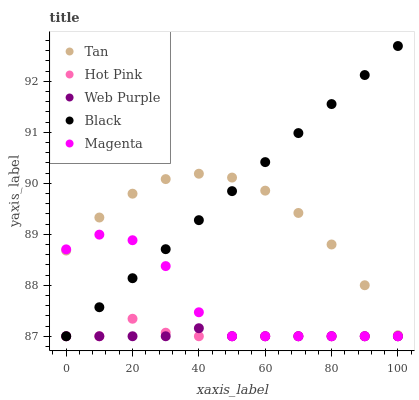Does Web Purple have the minimum area under the curve?
Answer yes or no. Yes. Does Black have the maximum area under the curve?
Answer yes or no. Yes. Does Hot Pink have the minimum area under the curve?
Answer yes or no. No. Does Hot Pink have the maximum area under the curve?
Answer yes or no. No. Is Black the smoothest?
Answer yes or no. Yes. Is Magenta the roughest?
Answer yes or no. Yes. Is Hot Pink the smoothest?
Answer yes or no. No. Is Hot Pink the roughest?
Answer yes or no. No. Does Hot Pink have the lowest value?
Answer yes or no. Yes. Does Black have the highest value?
Answer yes or no. Yes. Does Hot Pink have the highest value?
Answer yes or no. No. Is Web Purple less than Tan?
Answer yes or no. Yes. Is Tan greater than Hot Pink?
Answer yes or no. Yes. Does Magenta intersect Tan?
Answer yes or no. Yes. Is Magenta less than Tan?
Answer yes or no. No. Is Magenta greater than Tan?
Answer yes or no. No. Does Web Purple intersect Tan?
Answer yes or no. No. 